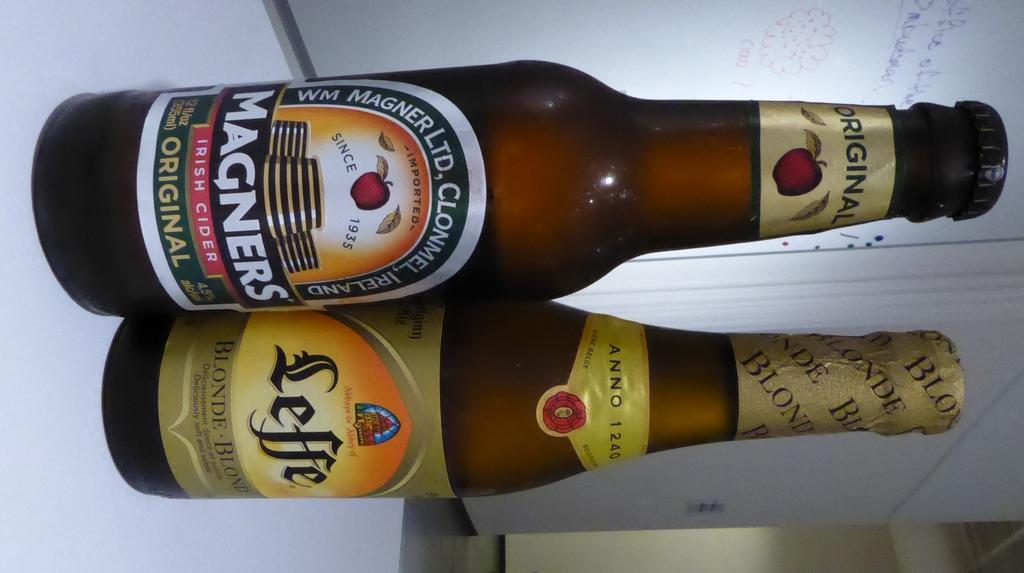<image>
Give a short and clear explanation of the subsequent image. A bottle of Magners Irish cider next to a bottle of Leffe. 